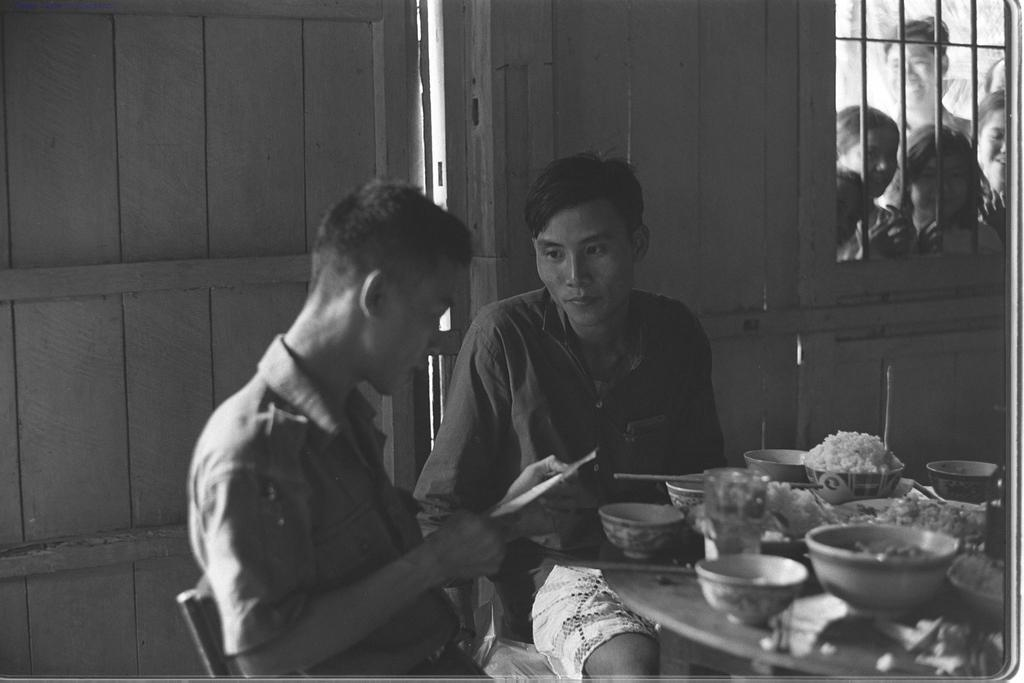How many people are sitting on chairs in the image? There are two men sitting on chairs in the image. What is on the table in the image? There are bowls on the table in the image. What is inside one of the bowls? There is food in a bowl in the image. What can be seen in the background of the image? There is a window and people visible in the background. What type of truck can be seen driving by in the image? There is no truck present in the image. What kind of club is visible in the background of the image? There is no club visible in the image; only a window and people can be seen in the background. 